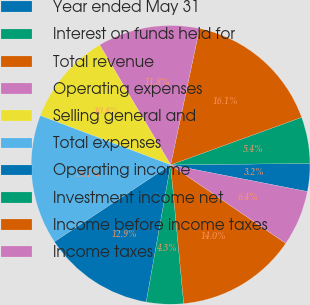Convert chart. <chart><loc_0><loc_0><loc_500><loc_500><pie_chart><fcel>Year ended May 31<fcel>Interest on funds held for<fcel>Total revenue<fcel>Operating expenses<fcel>Selling general and<fcel>Total expenses<fcel>Operating income<fcel>Investment income net<fcel>Income before income taxes<fcel>Income taxes<nl><fcel>3.23%<fcel>5.38%<fcel>16.13%<fcel>11.83%<fcel>10.75%<fcel>15.05%<fcel>12.9%<fcel>4.3%<fcel>13.98%<fcel>6.45%<nl></chart> 